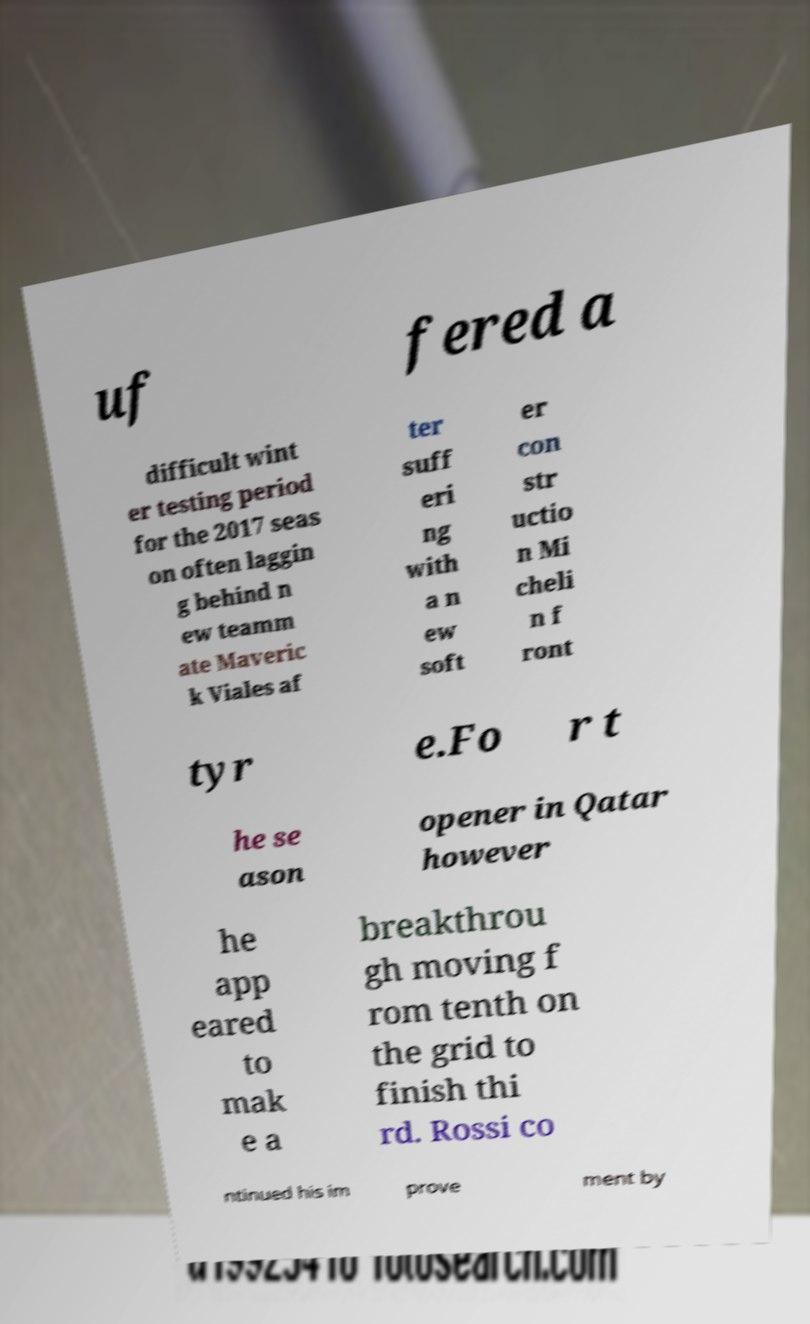There's text embedded in this image that I need extracted. Can you transcribe it verbatim? uf fered a difficult wint er testing period for the 2017 seas on often laggin g behind n ew teamm ate Maveric k Viales af ter suff eri ng with a n ew soft er con str uctio n Mi cheli n f ront tyr e.Fo r t he se ason opener in Qatar however he app eared to mak e a breakthrou gh moving f rom tenth on the grid to finish thi rd. Rossi co ntinued his im prove ment by 